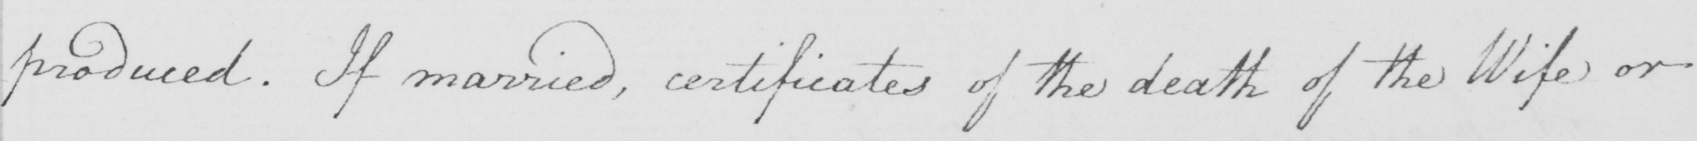Please transcribe the handwritten text in this image. produced. If married, certificates of the death of the Wife or 